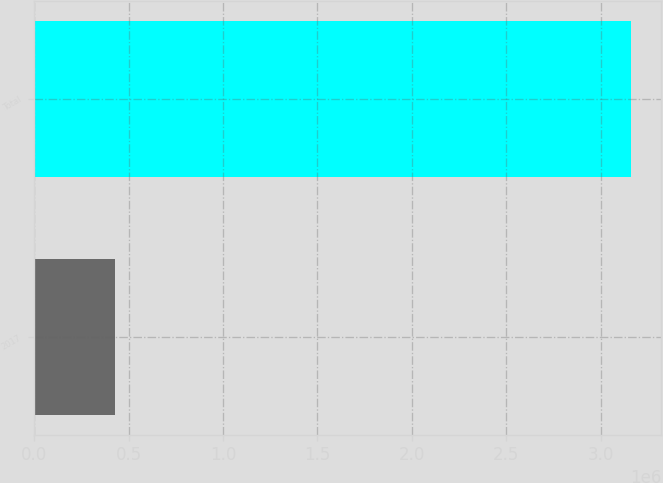Convert chart. <chart><loc_0><loc_0><loc_500><loc_500><bar_chart><fcel>2017<fcel>Total<nl><fcel>427912<fcel>3.16257e+06<nl></chart> 